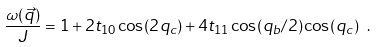<formula> <loc_0><loc_0><loc_500><loc_500>\frac { \omega ( \vec { q } ) } { J } = 1 + 2 t _ { 1 0 } \cos ( 2 q _ { c } ) + 4 t _ { 1 1 } \cos ( q _ { b } / 2 ) \cos ( q _ { c } ) \ .</formula> 